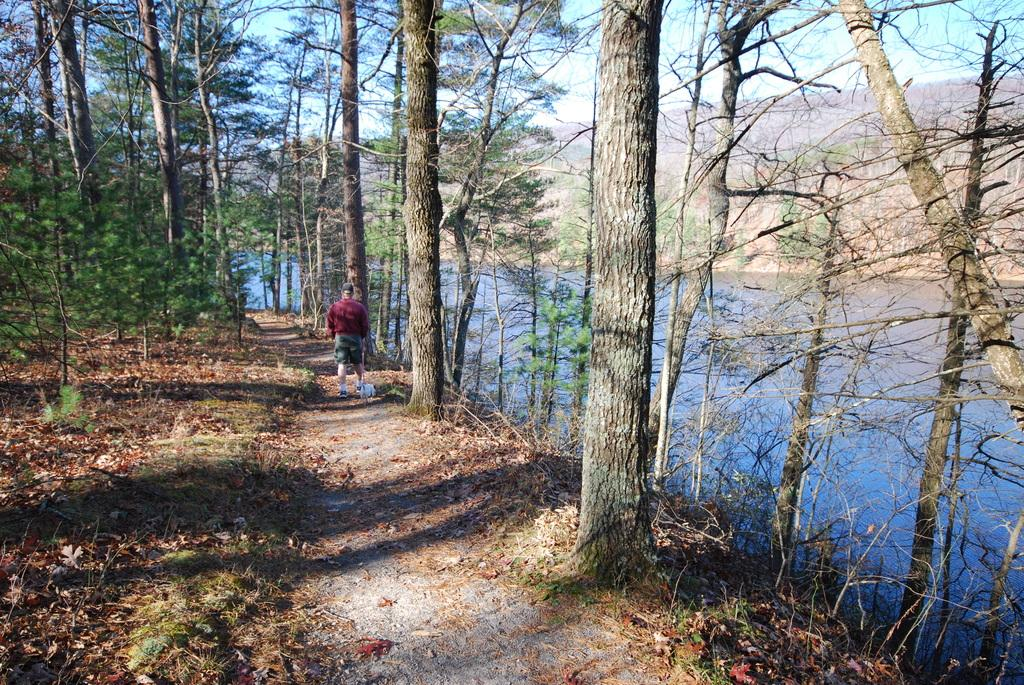What is the main subject in the image? There is a man standing in the image. What can be seen in the foreground of the image? There is a pathway in the image. What type of natural elements are present in the image? There are trees and water visible in the image. What is visible in the background of the image? There is a hill in the background of the image. What type of frame is around the man in the image? There is no frame around the man in the image; it is a photograph or digital image without a frame. What type of sheet is covering the trees in the image? There is no sheet covering the trees in the image; they are visible in their natural state. 